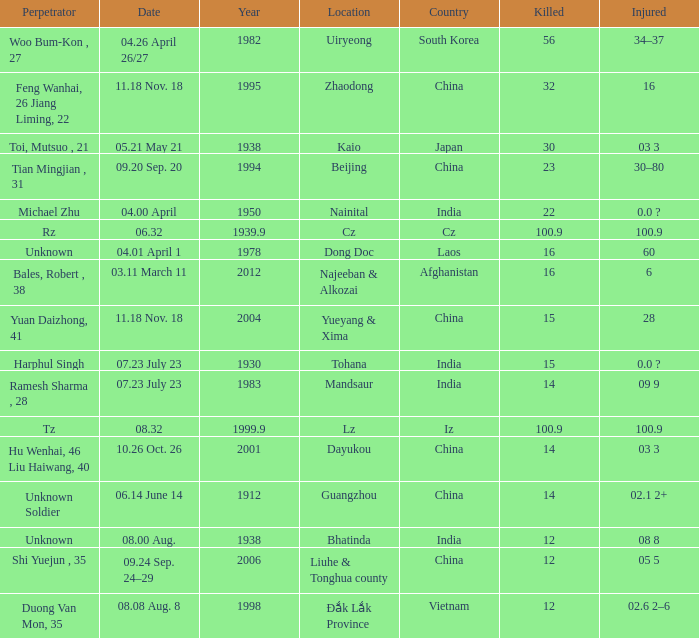What is Country, when Killed is "100.9", and when Year is greater than 1939.9? Iz. 